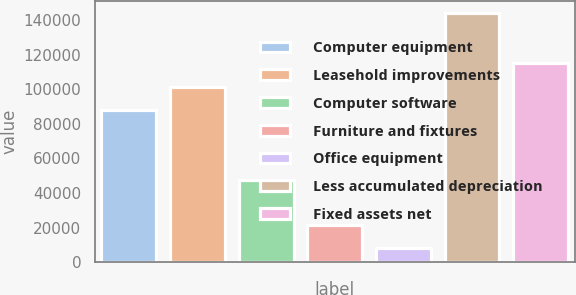Convert chart. <chart><loc_0><loc_0><loc_500><loc_500><bar_chart><fcel>Computer equipment<fcel>Leasehold improvements<fcel>Computer software<fcel>Furniture and fixtures<fcel>Office equipment<fcel>Less accumulated depreciation<fcel>Fixed assets net<nl><fcel>87926<fcel>101510<fcel>47702<fcel>21723.5<fcel>8139<fcel>143984<fcel>115095<nl></chart> 